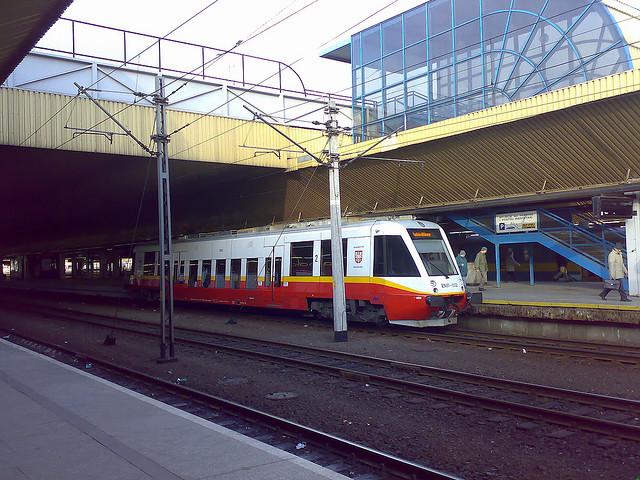Are the train's lights on?
Quick response, please. No. What type of station is this?
Be succinct. Train. Is it daytime or nighttime?
Answer briefly. Daytime. Where is the glass wall?
Give a very brief answer. Above train. How many trains are here?
Be succinct. 1. What class is this train?
Give a very brief answer. Passenger. What color is the train?
Write a very short answer. White/red. 